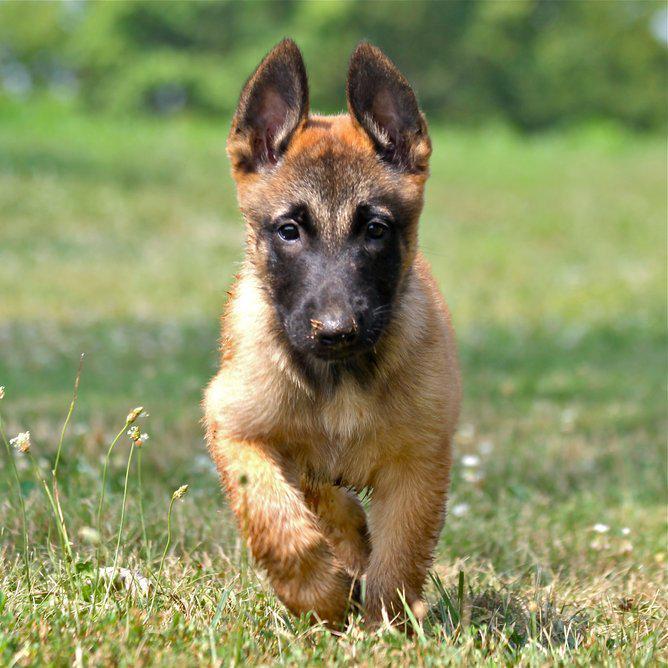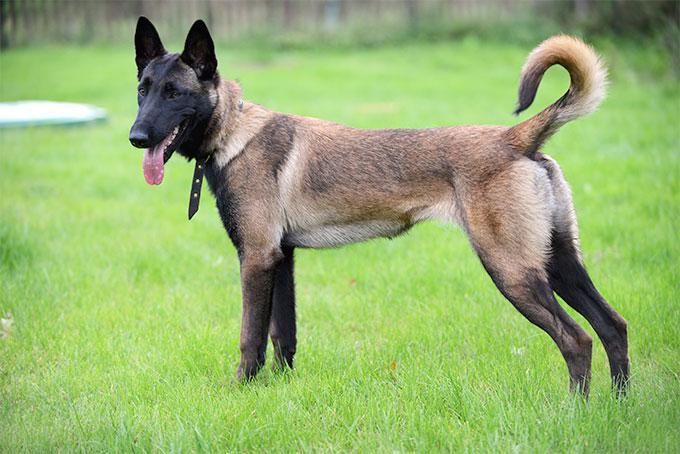The first image is the image on the left, the second image is the image on the right. Analyze the images presented: Is the assertion "The dog in the left image is attached to a leash." valid? Answer yes or no. No. The first image is the image on the left, the second image is the image on the right. Examine the images to the left and right. Is the description "At least one dog is sitting in the grass." accurate? Answer yes or no. No. 